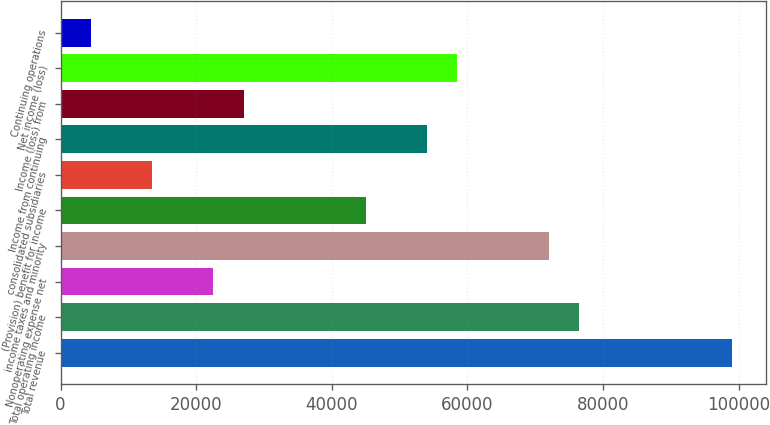Convert chart to OTSL. <chart><loc_0><loc_0><loc_500><loc_500><bar_chart><fcel>Total revenue<fcel>Total operating income<fcel>Nonoperating expense net<fcel>income taxes and minority<fcel>(Provision) benefit for income<fcel>consolidated subsidiaries<fcel>Income from continuing<fcel>Income (loss) from<fcel>Net income (loss)<fcel>Continuing operations<nl><fcel>98999.6<fcel>76499.8<fcel>22500.2<fcel>71999.8<fcel>45000<fcel>13500.2<fcel>53999.9<fcel>27000.1<fcel>58499.9<fcel>4500.27<nl></chart> 